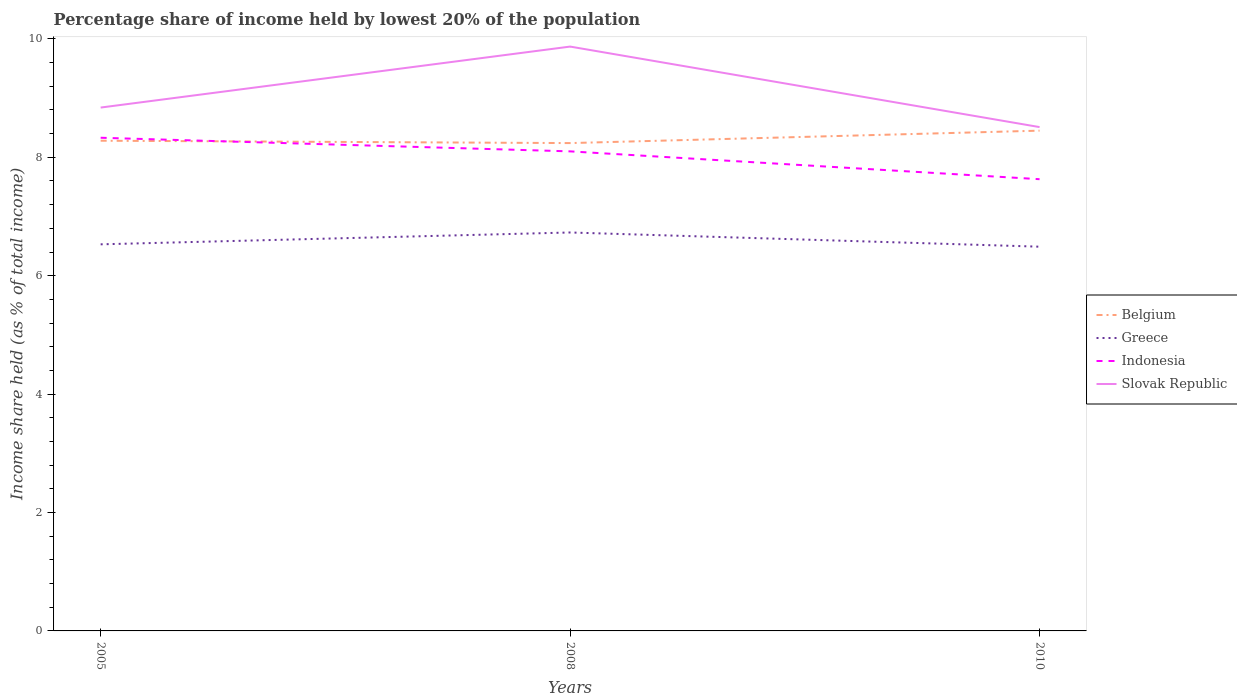Is the number of lines equal to the number of legend labels?
Give a very brief answer. Yes. Across all years, what is the maximum percentage share of income held by lowest 20% of the population in Greece?
Provide a short and direct response. 6.49. In which year was the percentage share of income held by lowest 20% of the population in Indonesia maximum?
Make the answer very short. 2010. What is the total percentage share of income held by lowest 20% of the population in Indonesia in the graph?
Your answer should be compact. 0.47. What is the difference between the highest and the second highest percentage share of income held by lowest 20% of the population in Belgium?
Offer a terse response. 0.21. Is the percentage share of income held by lowest 20% of the population in Belgium strictly greater than the percentage share of income held by lowest 20% of the population in Slovak Republic over the years?
Offer a terse response. Yes. How many lines are there?
Provide a short and direct response. 4. How many years are there in the graph?
Your response must be concise. 3. Are the values on the major ticks of Y-axis written in scientific E-notation?
Ensure brevity in your answer.  No. Does the graph contain grids?
Provide a short and direct response. No. Where does the legend appear in the graph?
Make the answer very short. Center right. How are the legend labels stacked?
Provide a succinct answer. Vertical. What is the title of the graph?
Provide a short and direct response. Percentage share of income held by lowest 20% of the population. What is the label or title of the Y-axis?
Provide a short and direct response. Income share held (as % of total income). What is the Income share held (as % of total income) in Belgium in 2005?
Give a very brief answer. 8.28. What is the Income share held (as % of total income) in Greece in 2005?
Give a very brief answer. 6.53. What is the Income share held (as % of total income) of Indonesia in 2005?
Provide a short and direct response. 8.33. What is the Income share held (as % of total income) of Slovak Republic in 2005?
Your response must be concise. 8.84. What is the Income share held (as % of total income) of Belgium in 2008?
Provide a succinct answer. 8.24. What is the Income share held (as % of total income) in Greece in 2008?
Ensure brevity in your answer.  6.73. What is the Income share held (as % of total income) in Indonesia in 2008?
Make the answer very short. 8.1. What is the Income share held (as % of total income) in Slovak Republic in 2008?
Give a very brief answer. 9.87. What is the Income share held (as % of total income) of Belgium in 2010?
Your response must be concise. 8.45. What is the Income share held (as % of total income) of Greece in 2010?
Your answer should be very brief. 6.49. What is the Income share held (as % of total income) of Indonesia in 2010?
Provide a succinct answer. 7.63. What is the Income share held (as % of total income) in Slovak Republic in 2010?
Offer a very short reply. 8.51. Across all years, what is the maximum Income share held (as % of total income) in Belgium?
Your answer should be compact. 8.45. Across all years, what is the maximum Income share held (as % of total income) in Greece?
Provide a short and direct response. 6.73. Across all years, what is the maximum Income share held (as % of total income) of Indonesia?
Your response must be concise. 8.33. Across all years, what is the maximum Income share held (as % of total income) in Slovak Republic?
Provide a short and direct response. 9.87. Across all years, what is the minimum Income share held (as % of total income) in Belgium?
Offer a very short reply. 8.24. Across all years, what is the minimum Income share held (as % of total income) in Greece?
Your answer should be very brief. 6.49. Across all years, what is the minimum Income share held (as % of total income) in Indonesia?
Ensure brevity in your answer.  7.63. Across all years, what is the minimum Income share held (as % of total income) of Slovak Republic?
Your answer should be very brief. 8.51. What is the total Income share held (as % of total income) of Belgium in the graph?
Provide a succinct answer. 24.97. What is the total Income share held (as % of total income) of Greece in the graph?
Give a very brief answer. 19.75. What is the total Income share held (as % of total income) in Indonesia in the graph?
Provide a short and direct response. 24.06. What is the total Income share held (as % of total income) in Slovak Republic in the graph?
Provide a succinct answer. 27.22. What is the difference between the Income share held (as % of total income) in Greece in 2005 and that in 2008?
Provide a succinct answer. -0.2. What is the difference between the Income share held (as % of total income) of Indonesia in 2005 and that in 2008?
Your response must be concise. 0.23. What is the difference between the Income share held (as % of total income) in Slovak Republic in 2005 and that in 2008?
Your answer should be very brief. -1.03. What is the difference between the Income share held (as % of total income) in Belgium in 2005 and that in 2010?
Your answer should be very brief. -0.17. What is the difference between the Income share held (as % of total income) of Slovak Republic in 2005 and that in 2010?
Keep it short and to the point. 0.33. What is the difference between the Income share held (as % of total income) of Belgium in 2008 and that in 2010?
Provide a short and direct response. -0.21. What is the difference between the Income share held (as % of total income) of Greece in 2008 and that in 2010?
Provide a short and direct response. 0.24. What is the difference between the Income share held (as % of total income) in Indonesia in 2008 and that in 2010?
Provide a succinct answer. 0.47. What is the difference between the Income share held (as % of total income) in Slovak Republic in 2008 and that in 2010?
Offer a very short reply. 1.36. What is the difference between the Income share held (as % of total income) in Belgium in 2005 and the Income share held (as % of total income) in Greece in 2008?
Offer a terse response. 1.55. What is the difference between the Income share held (as % of total income) in Belgium in 2005 and the Income share held (as % of total income) in Indonesia in 2008?
Your answer should be very brief. 0.18. What is the difference between the Income share held (as % of total income) of Belgium in 2005 and the Income share held (as % of total income) of Slovak Republic in 2008?
Give a very brief answer. -1.59. What is the difference between the Income share held (as % of total income) of Greece in 2005 and the Income share held (as % of total income) of Indonesia in 2008?
Your answer should be compact. -1.57. What is the difference between the Income share held (as % of total income) of Greece in 2005 and the Income share held (as % of total income) of Slovak Republic in 2008?
Your answer should be very brief. -3.34. What is the difference between the Income share held (as % of total income) in Indonesia in 2005 and the Income share held (as % of total income) in Slovak Republic in 2008?
Offer a terse response. -1.54. What is the difference between the Income share held (as % of total income) of Belgium in 2005 and the Income share held (as % of total income) of Greece in 2010?
Ensure brevity in your answer.  1.79. What is the difference between the Income share held (as % of total income) in Belgium in 2005 and the Income share held (as % of total income) in Indonesia in 2010?
Ensure brevity in your answer.  0.65. What is the difference between the Income share held (as % of total income) of Belgium in 2005 and the Income share held (as % of total income) of Slovak Republic in 2010?
Keep it short and to the point. -0.23. What is the difference between the Income share held (as % of total income) of Greece in 2005 and the Income share held (as % of total income) of Slovak Republic in 2010?
Give a very brief answer. -1.98. What is the difference between the Income share held (as % of total income) of Indonesia in 2005 and the Income share held (as % of total income) of Slovak Republic in 2010?
Your answer should be very brief. -0.18. What is the difference between the Income share held (as % of total income) in Belgium in 2008 and the Income share held (as % of total income) in Greece in 2010?
Your response must be concise. 1.75. What is the difference between the Income share held (as % of total income) of Belgium in 2008 and the Income share held (as % of total income) of Indonesia in 2010?
Offer a terse response. 0.61. What is the difference between the Income share held (as % of total income) of Belgium in 2008 and the Income share held (as % of total income) of Slovak Republic in 2010?
Provide a short and direct response. -0.27. What is the difference between the Income share held (as % of total income) in Greece in 2008 and the Income share held (as % of total income) in Indonesia in 2010?
Keep it short and to the point. -0.9. What is the difference between the Income share held (as % of total income) in Greece in 2008 and the Income share held (as % of total income) in Slovak Republic in 2010?
Provide a succinct answer. -1.78. What is the difference between the Income share held (as % of total income) of Indonesia in 2008 and the Income share held (as % of total income) of Slovak Republic in 2010?
Your answer should be compact. -0.41. What is the average Income share held (as % of total income) of Belgium per year?
Offer a terse response. 8.32. What is the average Income share held (as % of total income) in Greece per year?
Give a very brief answer. 6.58. What is the average Income share held (as % of total income) of Indonesia per year?
Your response must be concise. 8.02. What is the average Income share held (as % of total income) of Slovak Republic per year?
Offer a terse response. 9.07. In the year 2005, what is the difference between the Income share held (as % of total income) of Belgium and Income share held (as % of total income) of Indonesia?
Provide a short and direct response. -0.05. In the year 2005, what is the difference between the Income share held (as % of total income) in Belgium and Income share held (as % of total income) in Slovak Republic?
Offer a terse response. -0.56. In the year 2005, what is the difference between the Income share held (as % of total income) in Greece and Income share held (as % of total income) in Indonesia?
Provide a succinct answer. -1.8. In the year 2005, what is the difference between the Income share held (as % of total income) in Greece and Income share held (as % of total income) in Slovak Republic?
Provide a succinct answer. -2.31. In the year 2005, what is the difference between the Income share held (as % of total income) in Indonesia and Income share held (as % of total income) in Slovak Republic?
Your response must be concise. -0.51. In the year 2008, what is the difference between the Income share held (as % of total income) in Belgium and Income share held (as % of total income) in Greece?
Ensure brevity in your answer.  1.51. In the year 2008, what is the difference between the Income share held (as % of total income) of Belgium and Income share held (as % of total income) of Indonesia?
Your answer should be compact. 0.14. In the year 2008, what is the difference between the Income share held (as % of total income) in Belgium and Income share held (as % of total income) in Slovak Republic?
Your answer should be very brief. -1.63. In the year 2008, what is the difference between the Income share held (as % of total income) in Greece and Income share held (as % of total income) in Indonesia?
Make the answer very short. -1.37. In the year 2008, what is the difference between the Income share held (as % of total income) of Greece and Income share held (as % of total income) of Slovak Republic?
Make the answer very short. -3.14. In the year 2008, what is the difference between the Income share held (as % of total income) in Indonesia and Income share held (as % of total income) in Slovak Republic?
Provide a succinct answer. -1.77. In the year 2010, what is the difference between the Income share held (as % of total income) of Belgium and Income share held (as % of total income) of Greece?
Ensure brevity in your answer.  1.96. In the year 2010, what is the difference between the Income share held (as % of total income) of Belgium and Income share held (as % of total income) of Indonesia?
Make the answer very short. 0.82. In the year 2010, what is the difference between the Income share held (as % of total income) of Belgium and Income share held (as % of total income) of Slovak Republic?
Keep it short and to the point. -0.06. In the year 2010, what is the difference between the Income share held (as % of total income) in Greece and Income share held (as % of total income) in Indonesia?
Offer a terse response. -1.14. In the year 2010, what is the difference between the Income share held (as % of total income) of Greece and Income share held (as % of total income) of Slovak Republic?
Give a very brief answer. -2.02. In the year 2010, what is the difference between the Income share held (as % of total income) of Indonesia and Income share held (as % of total income) of Slovak Republic?
Your answer should be compact. -0.88. What is the ratio of the Income share held (as % of total income) of Greece in 2005 to that in 2008?
Ensure brevity in your answer.  0.97. What is the ratio of the Income share held (as % of total income) in Indonesia in 2005 to that in 2008?
Ensure brevity in your answer.  1.03. What is the ratio of the Income share held (as % of total income) in Slovak Republic in 2005 to that in 2008?
Offer a terse response. 0.9. What is the ratio of the Income share held (as % of total income) in Belgium in 2005 to that in 2010?
Your response must be concise. 0.98. What is the ratio of the Income share held (as % of total income) of Greece in 2005 to that in 2010?
Offer a very short reply. 1.01. What is the ratio of the Income share held (as % of total income) in Indonesia in 2005 to that in 2010?
Make the answer very short. 1.09. What is the ratio of the Income share held (as % of total income) of Slovak Republic in 2005 to that in 2010?
Provide a succinct answer. 1.04. What is the ratio of the Income share held (as % of total income) of Belgium in 2008 to that in 2010?
Offer a terse response. 0.98. What is the ratio of the Income share held (as % of total income) in Indonesia in 2008 to that in 2010?
Your answer should be compact. 1.06. What is the ratio of the Income share held (as % of total income) in Slovak Republic in 2008 to that in 2010?
Provide a succinct answer. 1.16. What is the difference between the highest and the second highest Income share held (as % of total income) of Belgium?
Keep it short and to the point. 0.17. What is the difference between the highest and the second highest Income share held (as % of total income) in Greece?
Make the answer very short. 0.2. What is the difference between the highest and the second highest Income share held (as % of total income) in Indonesia?
Keep it short and to the point. 0.23. What is the difference between the highest and the lowest Income share held (as % of total income) in Belgium?
Provide a short and direct response. 0.21. What is the difference between the highest and the lowest Income share held (as % of total income) in Greece?
Your response must be concise. 0.24. What is the difference between the highest and the lowest Income share held (as % of total income) of Indonesia?
Your answer should be very brief. 0.7. What is the difference between the highest and the lowest Income share held (as % of total income) in Slovak Republic?
Your response must be concise. 1.36. 